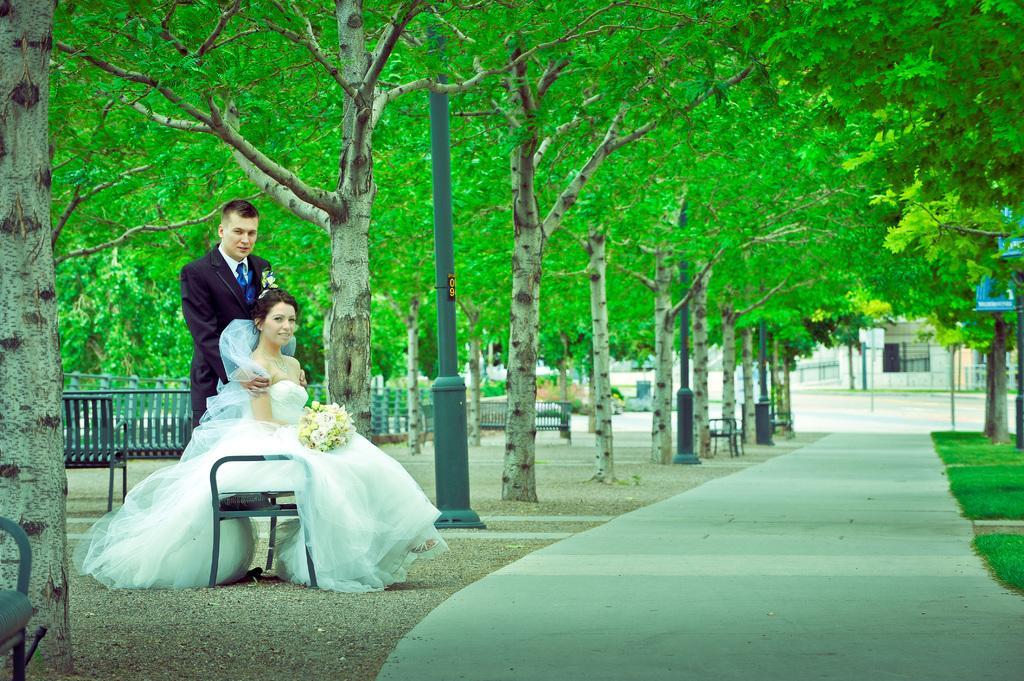Please provide a concise description of this image. In the picture we can see a pathway beside we can see a grass surface and trees on it and on the other side of the path we can see a grass surface with trees and a woman sitting on the bench and a man behind her standing and in the background we can see railing, and the bench. 